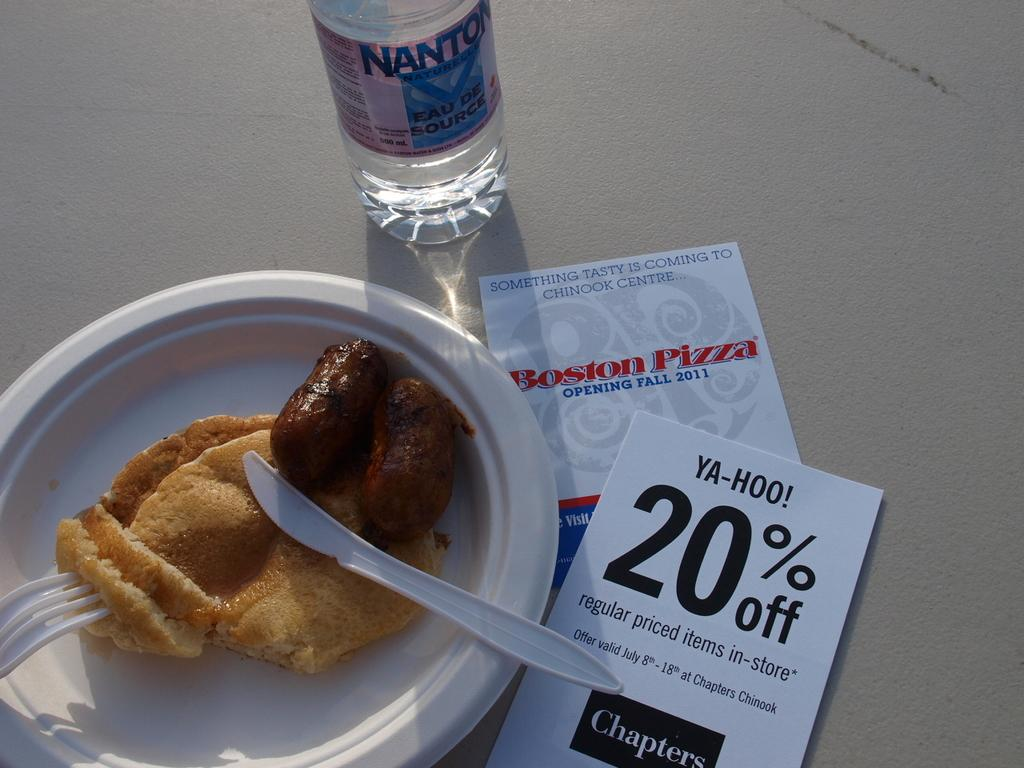What is located in the foreground of the image? There is a plate with food in the foreground of the image. What is on the plate? The plate contains food. What utensil is present on the plate? There is a fork in the plate. What other objects can be seen on the surface in the image? There is a bottle and two cards placed on the surface. What type of dress is the person wearing on their vacation in the image? There is no person or dress visible in the image; it only shows a plate with food, a fork, a bottle, and two cards. 